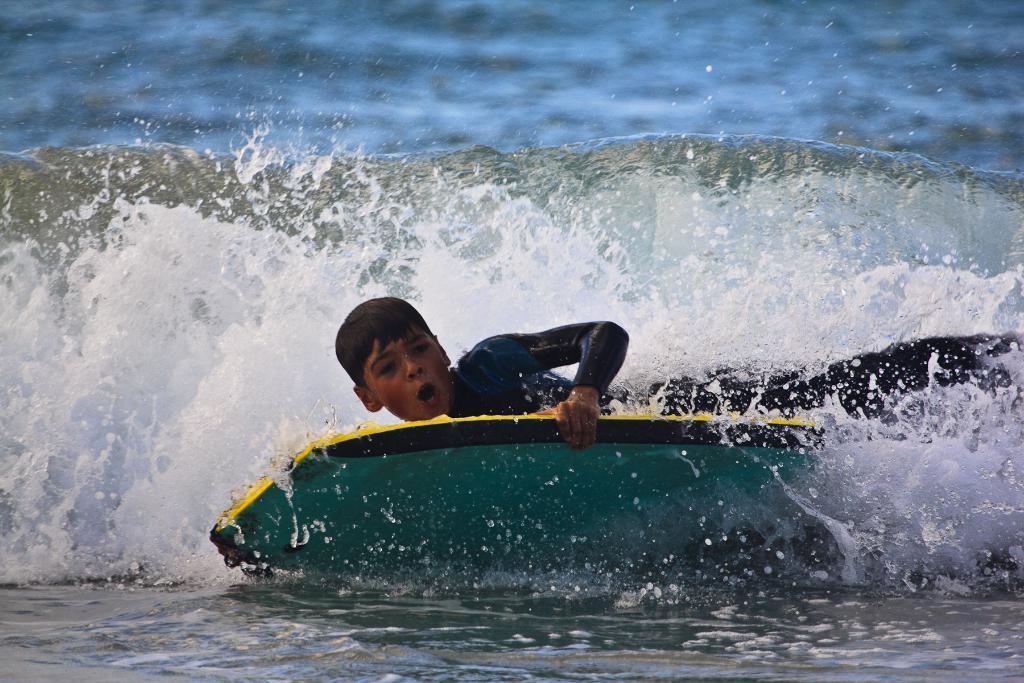Describe this image in one or two sentences. In the middle of the image a man is surfing on skateboard on the water. 